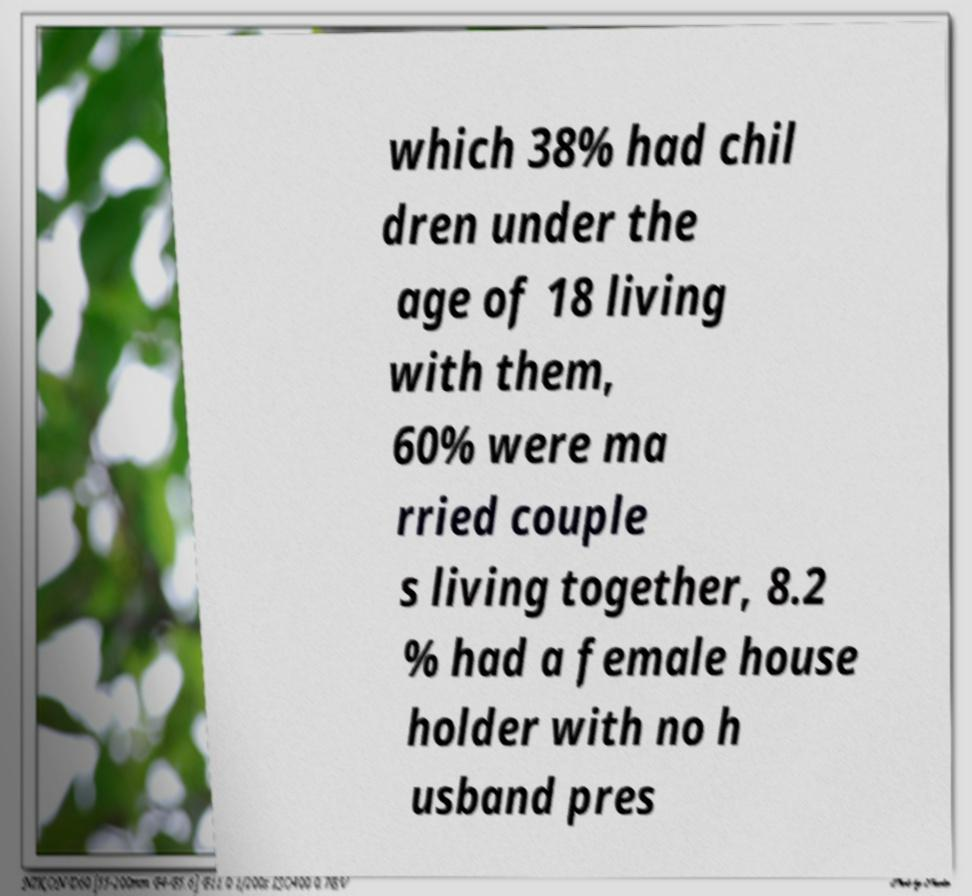For documentation purposes, I need the text within this image transcribed. Could you provide that? which 38% had chil dren under the age of 18 living with them, 60% were ma rried couple s living together, 8.2 % had a female house holder with no h usband pres 